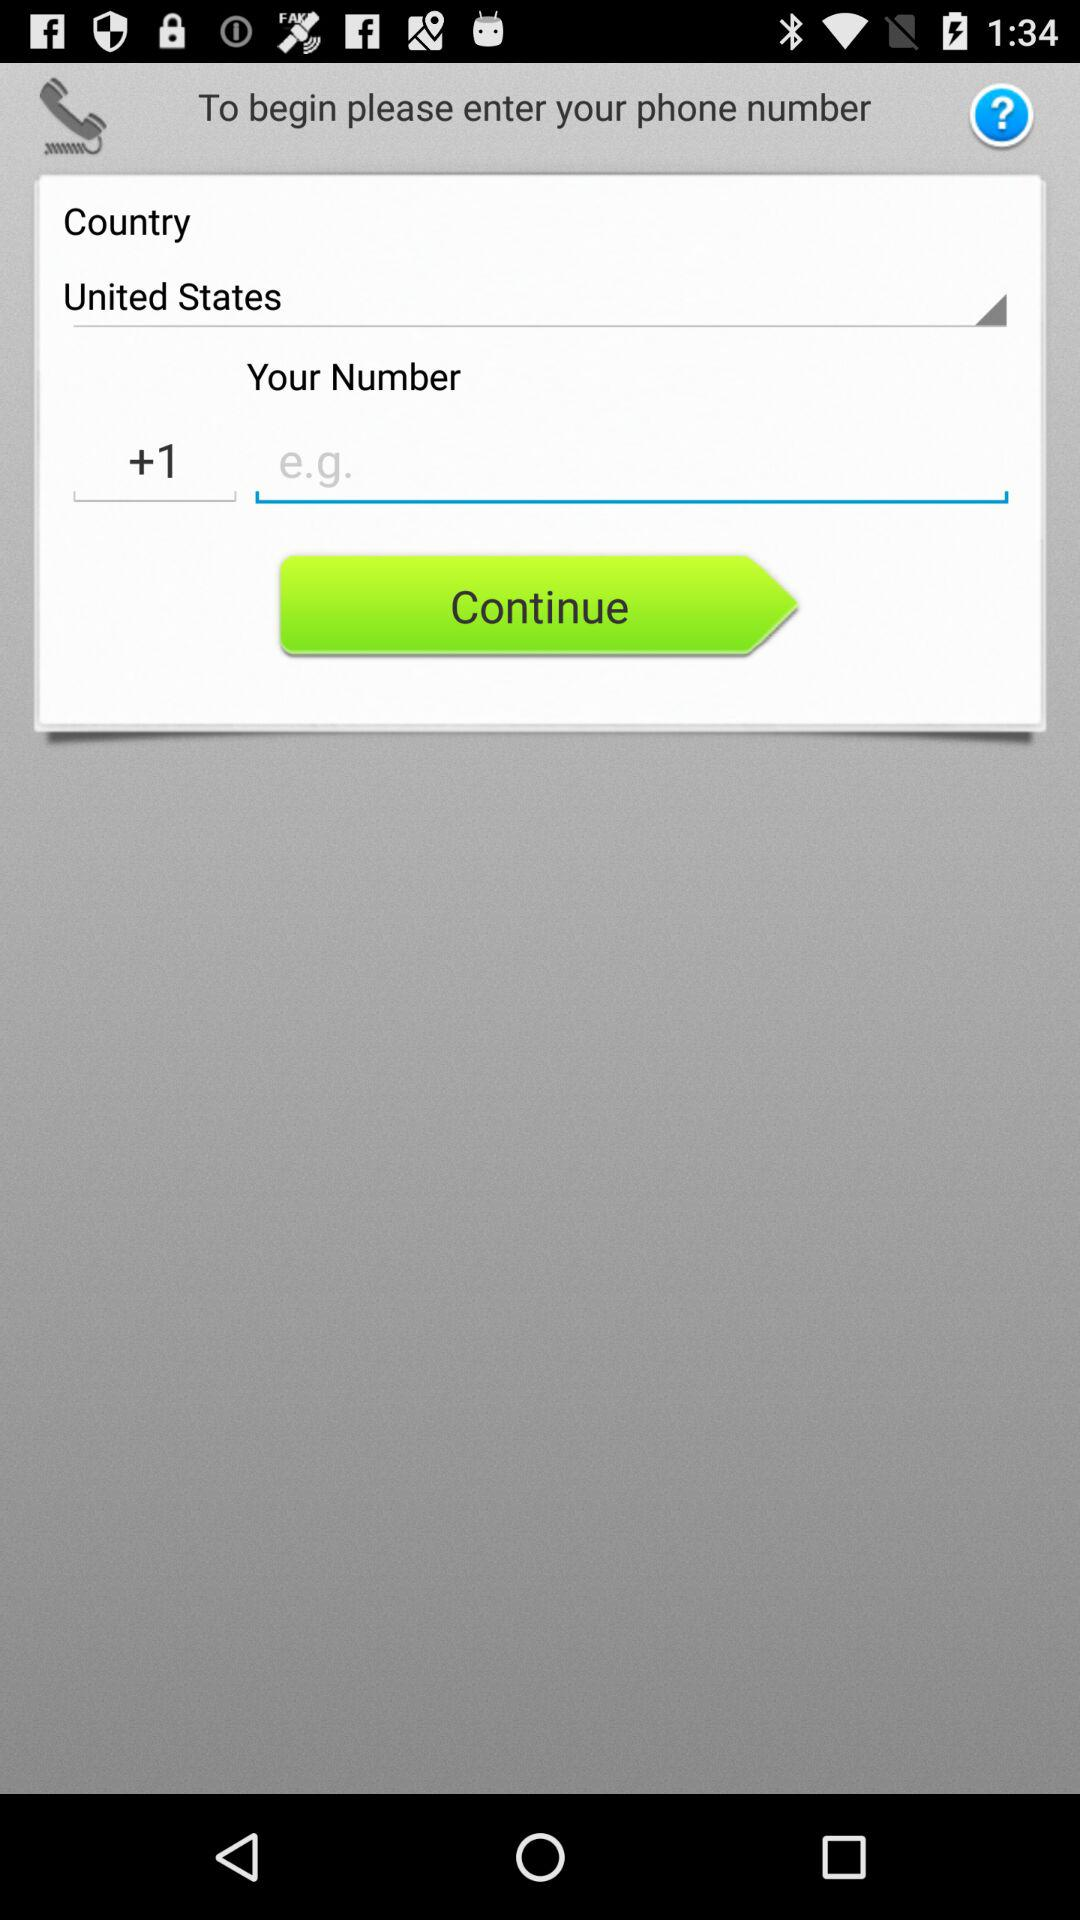What is the country code? The county code is +1. 